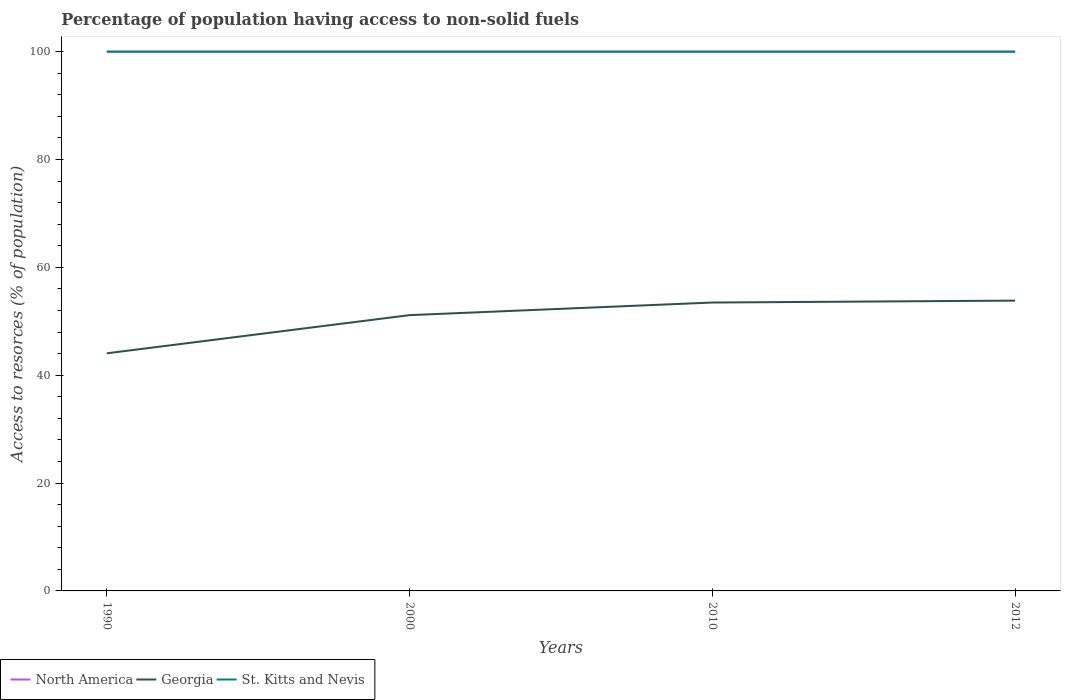How many different coloured lines are there?
Keep it short and to the point. 3. Does the line corresponding to St. Kitts and Nevis intersect with the line corresponding to Georgia?
Offer a terse response. No. Is the number of lines equal to the number of legend labels?
Your response must be concise. Yes. Across all years, what is the maximum percentage of population having access to non-solid fuels in North America?
Keep it short and to the point. 100. What is the difference between the highest and the second highest percentage of population having access to non-solid fuels in Georgia?
Offer a terse response. 9.78. What is the difference between the highest and the lowest percentage of population having access to non-solid fuels in St. Kitts and Nevis?
Offer a very short reply. 0. How many years are there in the graph?
Give a very brief answer. 4. What is the difference between two consecutive major ticks on the Y-axis?
Ensure brevity in your answer.  20. Does the graph contain any zero values?
Provide a short and direct response. No. Does the graph contain grids?
Your answer should be very brief. No. Where does the legend appear in the graph?
Offer a terse response. Bottom left. What is the title of the graph?
Your response must be concise. Percentage of population having access to non-solid fuels. What is the label or title of the Y-axis?
Provide a succinct answer. Access to resorces (% of population). What is the Access to resorces (% of population) of North America in 1990?
Ensure brevity in your answer.  100. What is the Access to resorces (% of population) of Georgia in 1990?
Offer a terse response. 44.06. What is the Access to resorces (% of population) of St. Kitts and Nevis in 1990?
Make the answer very short. 100. What is the Access to resorces (% of population) in Georgia in 2000?
Offer a terse response. 51.14. What is the Access to resorces (% of population) in Georgia in 2010?
Provide a succinct answer. 53.48. What is the Access to resorces (% of population) of North America in 2012?
Offer a terse response. 100. What is the Access to resorces (% of population) in Georgia in 2012?
Make the answer very short. 53.83. Across all years, what is the maximum Access to resorces (% of population) in Georgia?
Ensure brevity in your answer.  53.83. Across all years, what is the maximum Access to resorces (% of population) of St. Kitts and Nevis?
Offer a terse response. 100. Across all years, what is the minimum Access to resorces (% of population) in Georgia?
Offer a very short reply. 44.06. Across all years, what is the minimum Access to resorces (% of population) in St. Kitts and Nevis?
Ensure brevity in your answer.  100. What is the total Access to resorces (% of population) in North America in the graph?
Make the answer very short. 400. What is the total Access to resorces (% of population) in Georgia in the graph?
Provide a short and direct response. 202.51. What is the total Access to resorces (% of population) of St. Kitts and Nevis in the graph?
Make the answer very short. 400. What is the difference between the Access to resorces (% of population) of Georgia in 1990 and that in 2000?
Your response must be concise. -7.08. What is the difference between the Access to resorces (% of population) in St. Kitts and Nevis in 1990 and that in 2000?
Your answer should be very brief. 0. What is the difference between the Access to resorces (% of population) of Georgia in 1990 and that in 2010?
Offer a very short reply. -9.42. What is the difference between the Access to resorces (% of population) of North America in 1990 and that in 2012?
Offer a very short reply. 0. What is the difference between the Access to resorces (% of population) in Georgia in 1990 and that in 2012?
Offer a very short reply. -9.78. What is the difference between the Access to resorces (% of population) of North America in 2000 and that in 2010?
Your response must be concise. 0. What is the difference between the Access to resorces (% of population) of Georgia in 2000 and that in 2010?
Offer a very short reply. -2.33. What is the difference between the Access to resorces (% of population) in Georgia in 2000 and that in 2012?
Provide a succinct answer. -2.69. What is the difference between the Access to resorces (% of population) of North America in 2010 and that in 2012?
Ensure brevity in your answer.  0. What is the difference between the Access to resorces (% of population) of Georgia in 2010 and that in 2012?
Keep it short and to the point. -0.36. What is the difference between the Access to resorces (% of population) in North America in 1990 and the Access to resorces (% of population) in Georgia in 2000?
Provide a short and direct response. 48.86. What is the difference between the Access to resorces (% of population) in Georgia in 1990 and the Access to resorces (% of population) in St. Kitts and Nevis in 2000?
Your answer should be compact. -55.94. What is the difference between the Access to resorces (% of population) of North America in 1990 and the Access to resorces (% of population) of Georgia in 2010?
Provide a succinct answer. 46.52. What is the difference between the Access to resorces (% of population) in Georgia in 1990 and the Access to resorces (% of population) in St. Kitts and Nevis in 2010?
Provide a short and direct response. -55.94. What is the difference between the Access to resorces (% of population) in North America in 1990 and the Access to resorces (% of population) in Georgia in 2012?
Provide a succinct answer. 46.17. What is the difference between the Access to resorces (% of population) of Georgia in 1990 and the Access to resorces (% of population) of St. Kitts and Nevis in 2012?
Offer a terse response. -55.94. What is the difference between the Access to resorces (% of population) of North America in 2000 and the Access to resorces (% of population) of Georgia in 2010?
Keep it short and to the point. 46.52. What is the difference between the Access to resorces (% of population) in North America in 2000 and the Access to resorces (% of population) in St. Kitts and Nevis in 2010?
Your response must be concise. 0. What is the difference between the Access to resorces (% of population) of Georgia in 2000 and the Access to resorces (% of population) of St. Kitts and Nevis in 2010?
Provide a short and direct response. -48.86. What is the difference between the Access to resorces (% of population) of North America in 2000 and the Access to resorces (% of population) of Georgia in 2012?
Provide a succinct answer. 46.17. What is the difference between the Access to resorces (% of population) of North America in 2000 and the Access to resorces (% of population) of St. Kitts and Nevis in 2012?
Offer a very short reply. 0. What is the difference between the Access to resorces (% of population) in Georgia in 2000 and the Access to resorces (% of population) in St. Kitts and Nevis in 2012?
Provide a succinct answer. -48.86. What is the difference between the Access to resorces (% of population) of North America in 2010 and the Access to resorces (% of population) of Georgia in 2012?
Offer a terse response. 46.17. What is the difference between the Access to resorces (% of population) in North America in 2010 and the Access to resorces (% of population) in St. Kitts and Nevis in 2012?
Keep it short and to the point. 0. What is the difference between the Access to resorces (% of population) in Georgia in 2010 and the Access to resorces (% of population) in St. Kitts and Nevis in 2012?
Your response must be concise. -46.52. What is the average Access to resorces (% of population) in Georgia per year?
Your answer should be very brief. 50.63. In the year 1990, what is the difference between the Access to resorces (% of population) of North America and Access to resorces (% of population) of Georgia?
Ensure brevity in your answer.  55.94. In the year 1990, what is the difference between the Access to resorces (% of population) of Georgia and Access to resorces (% of population) of St. Kitts and Nevis?
Give a very brief answer. -55.94. In the year 2000, what is the difference between the Access to resorces (% of population) in North America and Access to resorces (% of population) in Georgia?
Keep it short and to the point. 48.86. In the year 2000, what is the difference between the Access to resorces (% of population) of Georgia and Access to resorces (% of population) of St. Kitts and Nevis?
Make the answer very short. -48.86. In the year 2010, what is the difference between the Access to resorces (% of population) in North America and Access to resorces (% of population) in Georgia?
Keep it short and to the point. 46.52. In the year 2010, what is the difference between the Access to resorces (% of population) in North America and Access to resorces (% of population) in St. Kitts and Nevis?
Your answer should be compact. 0. In the year 2010, what is the difference between the Access to resorces (% of population) of Georgia and Access to resorces (% of population) of St. Kitts and Nevis?
Your answer should be compact. -46.52. In the year 2012, what is the difference between the Access to resorces (% of population) in North America and Access to resorces (% of population) in Georgia?
Offer a very short reply. 46.17. In the year 2012, what is the difference between the Access to resorces (% of population) of North America and Access to resorces (% of population) of St. Kitts and Nevis?
Provide a short and direct response. 0. In the year 2012, what is the difference between the Access to resorces (% of population) in Georgia and Access to resorces (% of population) in St. Kitts and Nevis?
Keep it short and to the point. -46.17. What is the ratio of the Access to resorces (% of population) in Georgia in 1990 to that in 2000?
Provide a short and direct response. 0.86. What is the ratio of the Access to resorces (% of population) of St. Kitts and Nevis in 1990 to that in 2000?
Ensure brevity in your answer.  1. What is the ratio of the Access to resorces (% of population) of Georgia in 1990 to that in 2010?
Your response must be concise. 0.82. What is the ratio of the Access to resorces (% of population) in North America in 1990 to that in 2012?
Give a very brief answer. 1. What is the ratio of the Access to resorces (% of population) of Georgia in 1990 to that in 2012?
Give a very brief answer. 0.82. What is the ratio of the Access to resorces (% of population) in St. Kitts and Nevis in 1990 to that in 2012?
Your response must be concise. 1. What is the ratio of the Access to resorces (% of population) of North America in 2000 to that in 2010?
Offer a terse response. 1. What is the ratio of the Access to resorces (% of population) of Georgia in 2000 to that in 2010?
Your answer should be very brief. 0.96. What is the ratio of the Access to resorces (% of population) in Georgia in 2000 to that in 2012?
Your answer should be very brief. 0.95. What is the ratio of the Access to resorces (% of population) of St. Kitts and Nevis in 2010 to that in 2012?
Offer a very short reply. 1. What is the difference between the highest and the second highest Access to resorces (% of population) in Georgia?
Provide a short and direct response. 0.36. What is the difference between the highest and the lowest Access to resorces (% of population) of North America?
Your answer should be compact. 0. What is the difference between the highest and the lowest Access to resorces (% of population) of Georgia?
Provide a succinct answer. 9.78. 